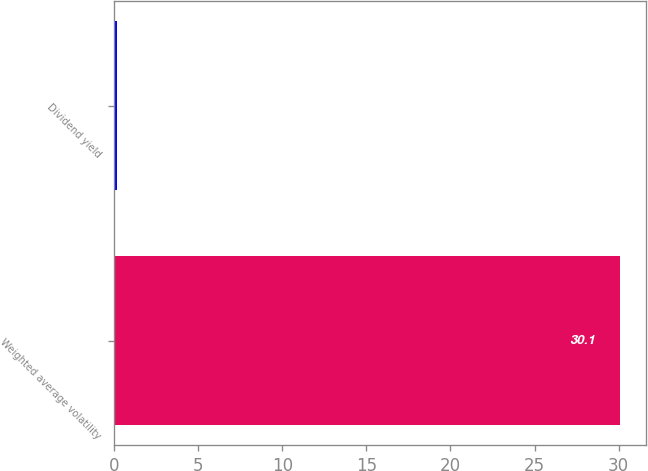Convert chart to OTSL. <chart><loc_0><loc_0><loc_500><loc_500><bar_chart><fcel>Weighted average volatility<fcel>Dividend yield<nl><fcel>30.1<fcel>0.2<nl></chart> 